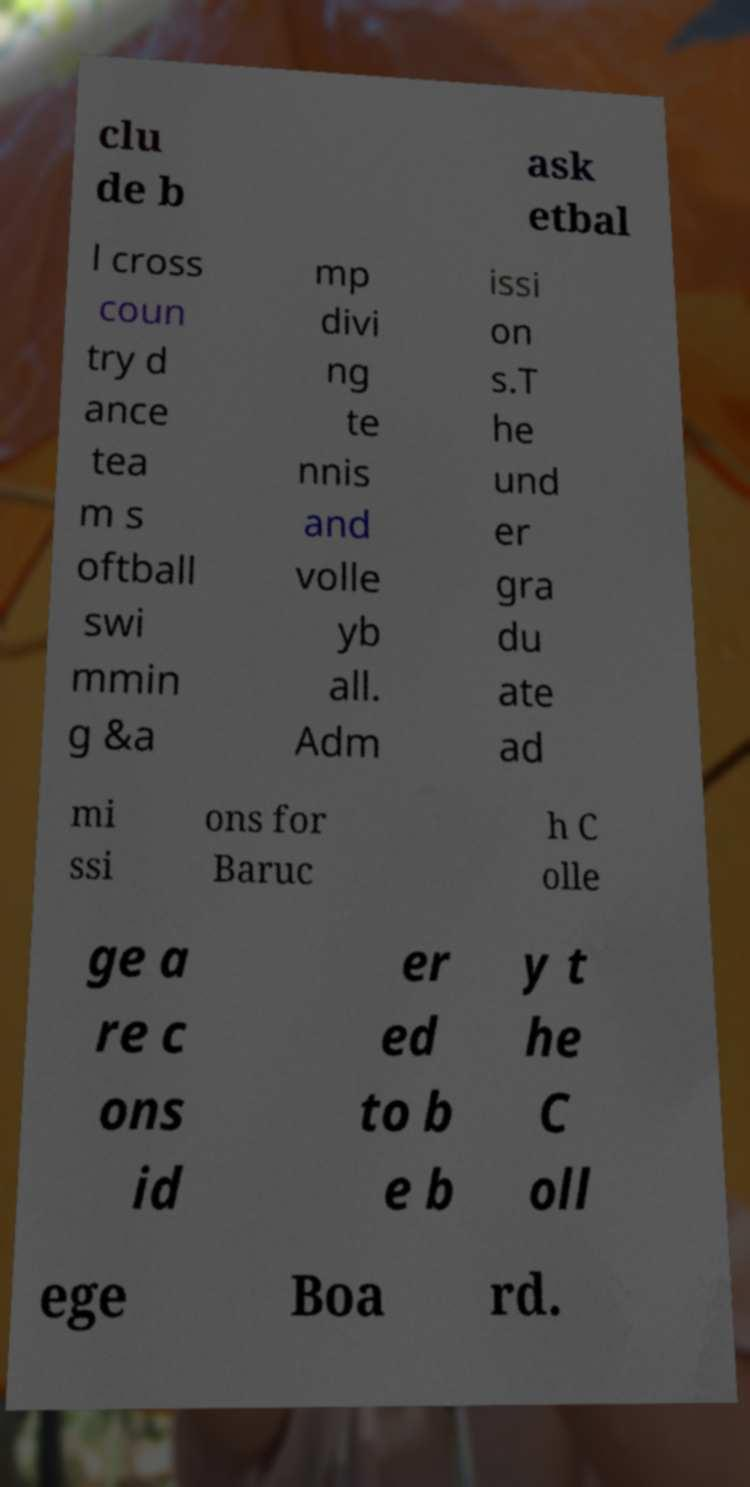Could you extract and type out the text from this image? clu de b ask etbal l cross coun try d ance tea m s oftball swi mmin g &a mp divi ng te nnis and volle yb all. Adm issi on s.T he und er gra du ate ad mi ssi ons for Baruc h C olle ge a re c ons id er ed to b e b y t he C oll ege Boa rd. 